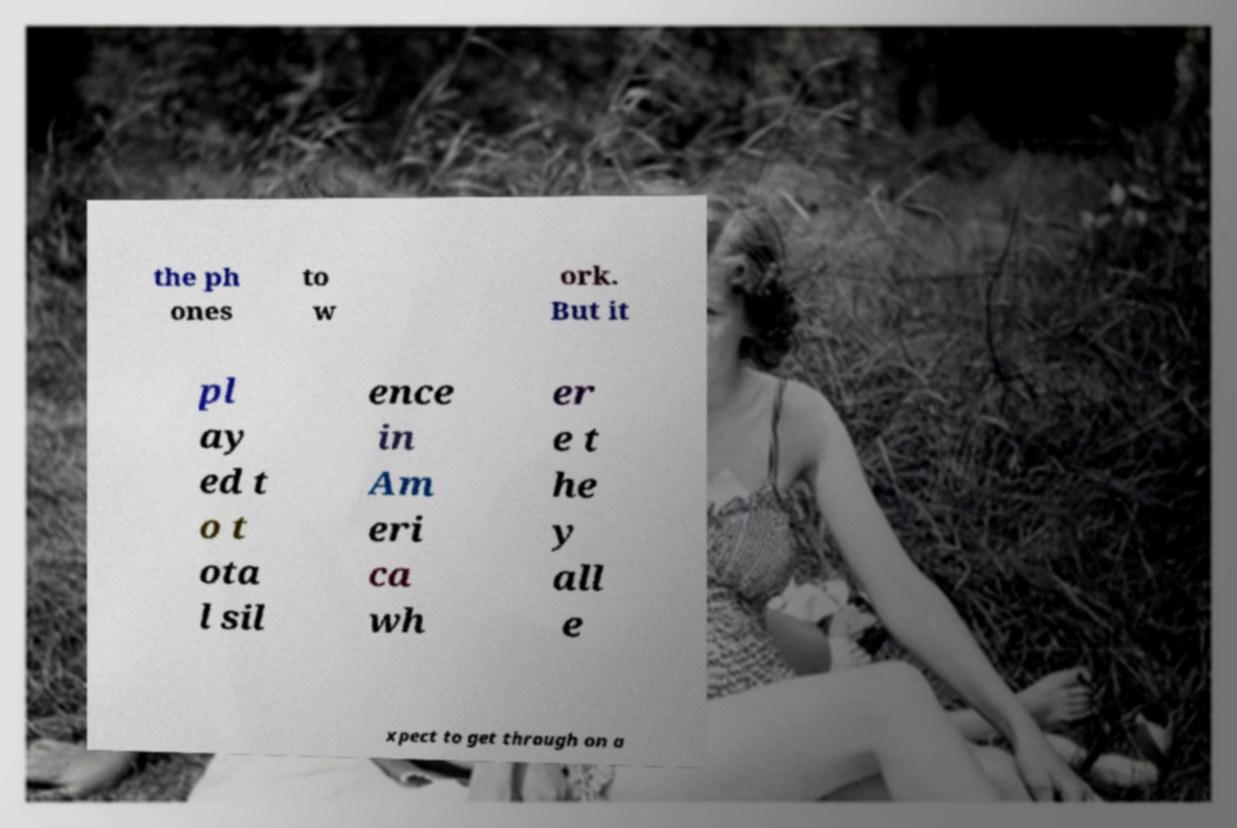Could you extract and type out the text from this image? the ph ones to w ork. But it pl ay ed t o t ota l sil ence in Am eri ca wh er e t he y all e xpect to get through on a 